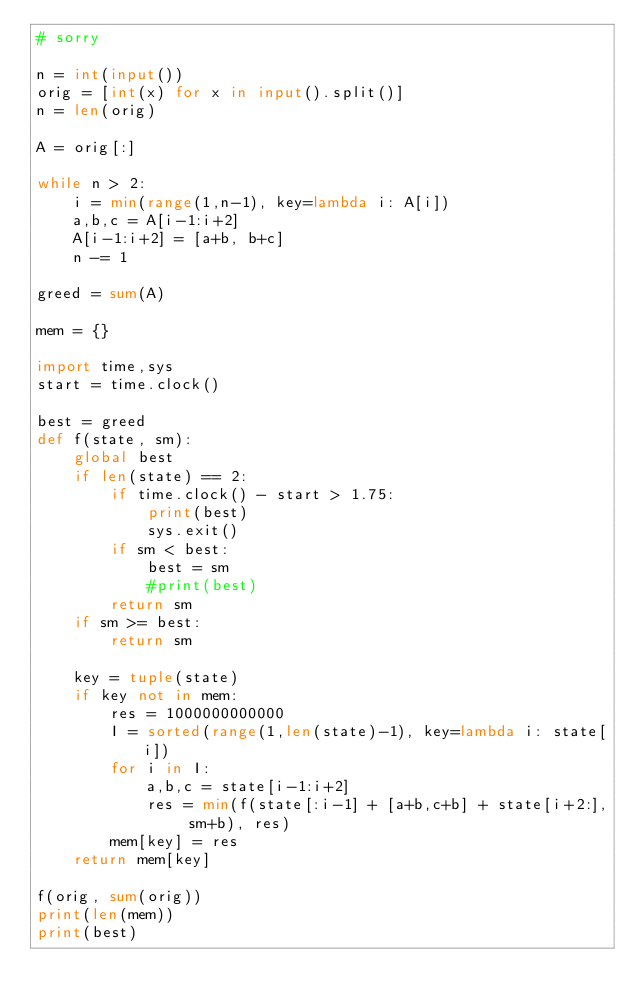Convert code to text. <code><loc_0><loc_0><loc_500><loc_500><_Python_># sorry

n = int(input())
orig = [int(x) for x in input().split()]
n = len(orig)

A = orig[:]

while n > 2:
    i = min(range(1,n-1), key=lambda i: A[i])
    a,b,c = A[i-1:i+2]
    A[i-1:i+2] = [a+b, b+c]
    n -= 1

greed = sum(A)

mem = {}

import time,sys
start = time.clock()

best = greed
def f(state, sm):
    global best
    if len(state) == 2:
        if time.clock() - start > 1.75:
            print(best)
            sys.exit()
        if sm < best:
            best = sm
            #print(best)
        return sm
    if sm >= best:
        return sm

    key = tuple(state)
    if key not in mem:
        res = 1000000000000
        I = sorted(range(1,len(state)-1), key=lambda i: state[i])
        for i in I:
            a,b,c = state[i-1:i+2]
            res = min(f(state[:i-1] + [a+b,c+b] + state[i+2:], sm+b), res)
        mem[key] = res
    return mem[key]

f(orig, sum(orig))
print(len(mem))
print(best)
</code> 